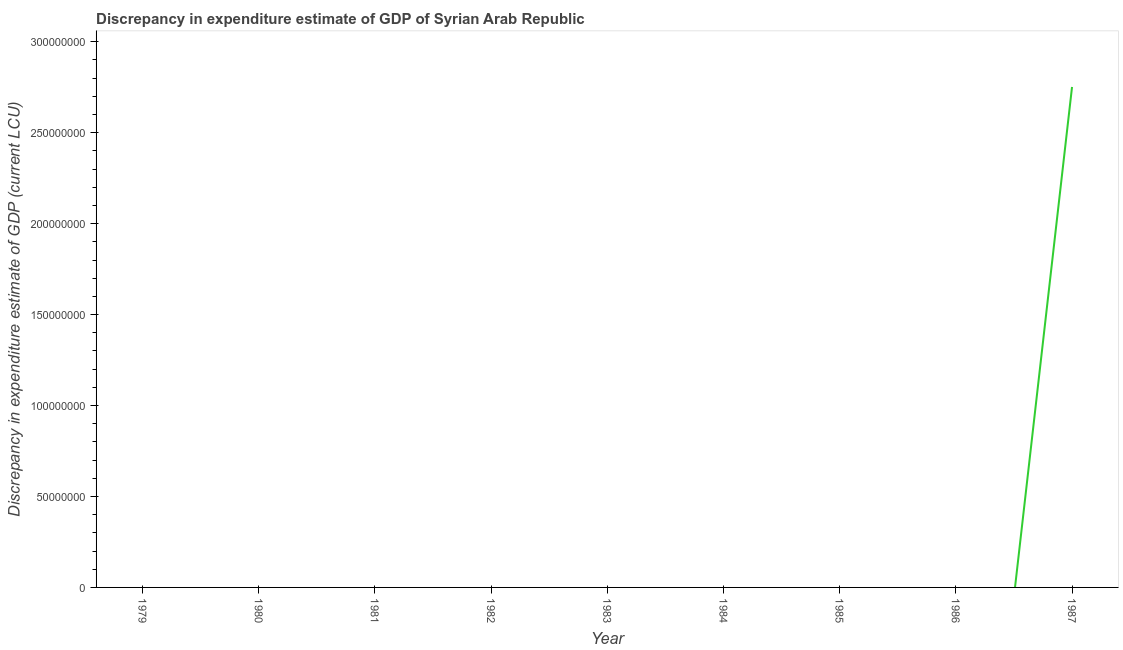Across all years, what is the maximum discrepancy in expenditure estimate of gdp?
Provide a short and direct response. 2.75e+08. What is the sum of the discrepancy in expenditure estimate of gdp?
Your answer should be very brief. 2.75e+08. What is the average discrepancy in expenditure estimate of gdp per year?
Your answer should be very brief. 3.06e+07. In how many years, is the discrepancy in expenditure estimate of gdp greater than 30000000 LCU?
Offer a very short reply. 1. What is the difference between the highest and the lowest discrepancy in expenditure estimate of gdp?
Keep it short and to the point. 2.75e+08. Does the discrepancy in expenditure estimate of gdp monotonically increase over the years?
Your answer should be very brief. No. How many lines are there?
Your answer should be compact. 1. What is the title of the graph?
Ensure brevity in your answer.  Discrepancy in expenditure estimate of GDP of Syrian Arab Republic. What is the label or title of the X-axis?
Offer a very short reply. Year. What is the label or title of the Y-axis?
Your answer should be compact. Discrepancy in expenditure estimate of GDP (current LCU). What is the Discrepancy in expenditure estimate of GDP (current LCU) in 1981?
Give a very brief answer. 0. What is the Discrepancy in expenditure estimate of GDP (current LCU) in 1982?
Ensure brevity in your answer.  0. What is the Discrepancy in expenditure estimate of GDP (current LCU) of 1986?
Your answer should be compact. 0. What is the Discrepancy in expenditure estimate of GDP (current LCU) in 1987?
Your answer should be compact. 2.75e+08. 